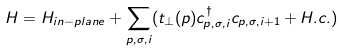Convert formula to latex. <formula><loc_0><loc_0><loc_500><loc_500>H = H _ { i n - p l a n e } + \sum _ { p , \sigma , i } ( t _ { \perp } ( p ) c _ { p , \sigma , i } ^ { \dagger } c _ { p , \sigma , i + 1 } + H . c . )</formula> 